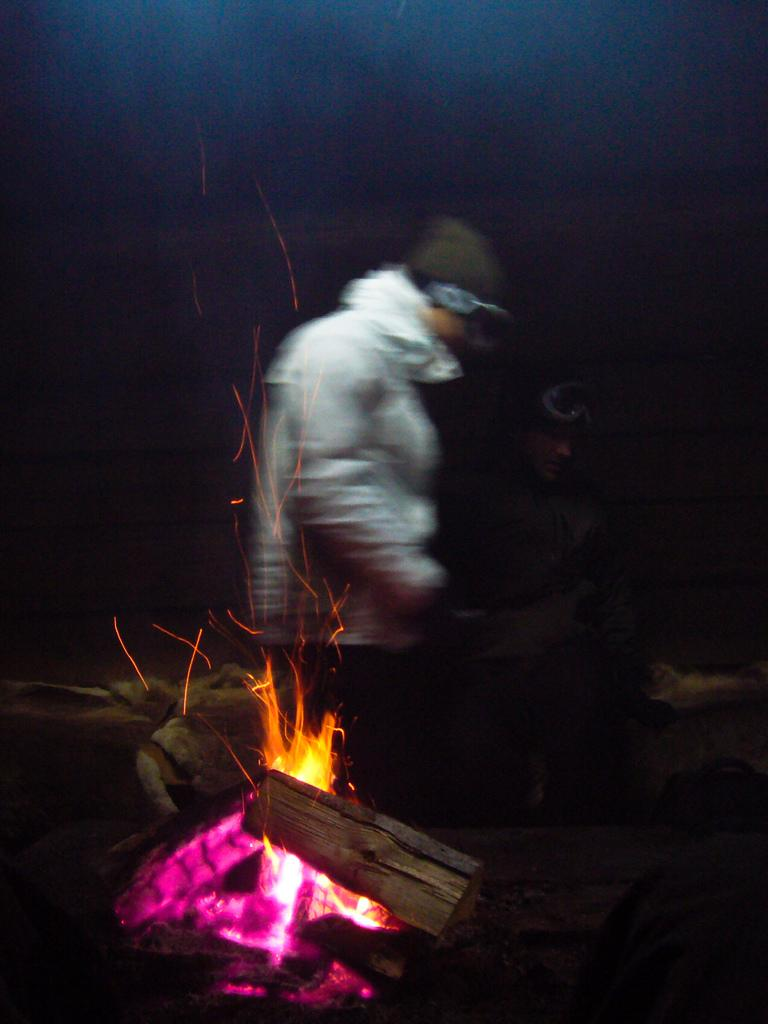What is happening in the foreground of the image? There is a flame and wood burning in the foreground of the image. How many people are in the image? There are two persons in the image. What are the two persons wearing? The two persons are wearing jackets. What can be observed about the background of the image? The background of the image is dark. What type of loss is the horse experiencing in the image? There is no horse present in the image, so it is not possible to determine any loss experienced by a horse. 